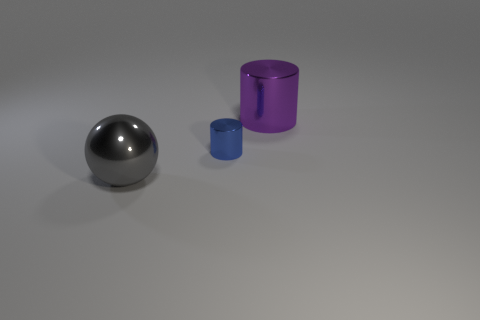Is there anything else that is the same size as the blue shiny cylinder?
Your answer should be very brief. No. There is a gray thing; is it the same shape as the big object behind the gray sphere?
Keep it short and to the point. No. There is a object that is both behind the gray shiny ball and to the left of the purple cylinder; what is its size?
Keep it short and to the point. Small. What is the shape of the gray thing?
Make the answer very short. Sphere. There is a large thing that is behind the metallic ball; is there a big metal sphere that is to the right of it?
Offer a very short reply. No. How many big gray metal spheres are to the left of the thing behind the blue cylinder?
Ensure brevity in your answer.  1. What material is the gray ball that is the same size as the purple metal cylinder?
Provide a short and direct response. Metal. There is a big metallic object that is on the left side of the large cylinder; is its shape the same as the tiny object?
Give a very brief answer. No. Is the number of shiny things that are in front of the tiny thing greater than the number of big metal objects right of the big purple thing?
Keep it short and to the point. Yes. How many tiny cylinders have the same material as the large ball?
Your answer should be very brief. 1. 